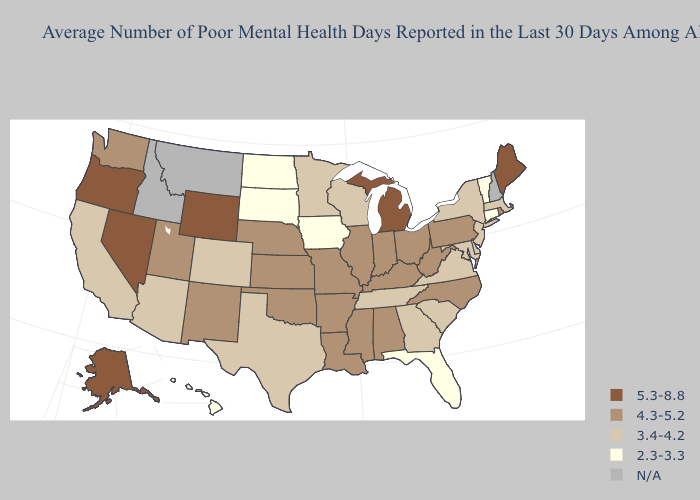Name the states that have a value in the range 5.3-8.8?
Keep it brief. Alaska, Maine, Michigan, Nevada, Oregon, Wyoming. Does Rhode Island have the highest value in the USA?
Answer briefly. No. What is the lowest value in the South?
Answer briefly. 2.3-3.3. Name the states that have a value in the range 3.4-4.2?
Write a very short answer. Arizona, California, Colorado, Delaware, Georgia, Maryland, Massachusetts, Minnesota, New Jersey, New York, South Carolina, Tennessee, Texas, Virginia, Wisconsin. How many symbols are there in the legend?
Give a very brief answer. 5. Name the states that have a value in the range 5.3-8.8?
Write a very short answer. Alaska, Maine, Michigan, Nevada, Oregon, Wyoming. What is the highest value in states that border South Carolina?
Keep it brief. 4.3-5.2. Among the states that border Arkansas , which have the lowest value?
Quick response, please. Tennessee, Texas. Does Utah have the highest value in the West?
Short answer required. No. Among the states that border Oklahoma , which have the highest value?
Give a very brief answer. Arkansas, Kansas, Missouri, New Mexico. What is the value of North Carolina?
Answer briefly. 4.3-5.2. Is the legend a continuous bar?
Concise answer only. No. What is the highest value in the South ?
Write a very short answer. 4.3-5.2. 